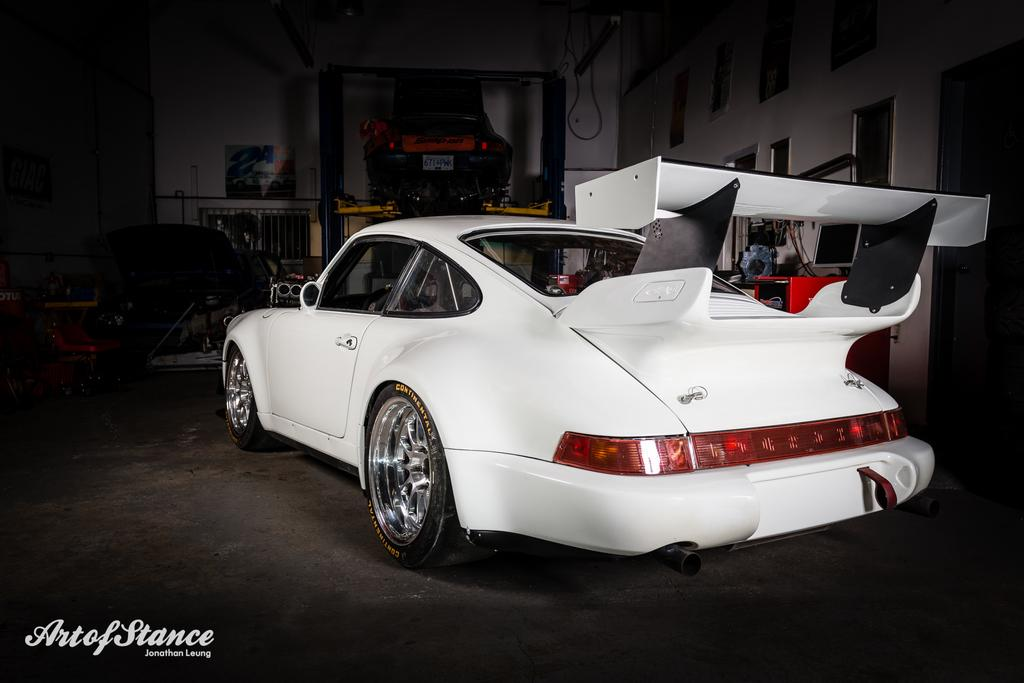What is the main subject of the image? The main subject of the image is a car. Can you describe the surroundings of the car? There are some equipment around the car. What type of pancake is being served on the car's hood in the image? There is no pancake present in the image; it only features a car and some equipment around it. 